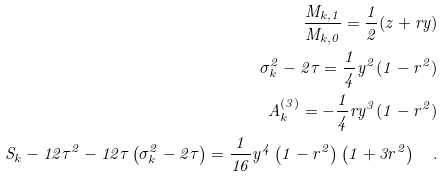<formula> <loc_0><loc_0><loc_500><loc_500>\frac { M _ { k , 1 } } { M _ { k , 0 } } = \frac { 1 } { 2 } ( z + r y ) \\ \sigma _ { k } ^ { 2 } - 2 \tau = \frac { 1 } { 4 } y ^ { 2 } ( 1 - r ^ { 2 } ) \\ A _ { k } ^ { ( 3 ) } = - \frac { 1 } { 4 } r y ^ { 3 } ( 1 - r ^ { 2 } ) \\ S _ { k } - 1 2 \tau ^ { 2 } - 1 2 \tau \left ( \sigma _ { k } ^ { 2 } - 2 \tau \right ) = \frac { 1 } { 1 6 } y ^ { 4 } \left ( 1 - r ^ { 2 } \right ) \left ( 1 + 3 r ^ { 2 } \right ) \quad .</formula> 